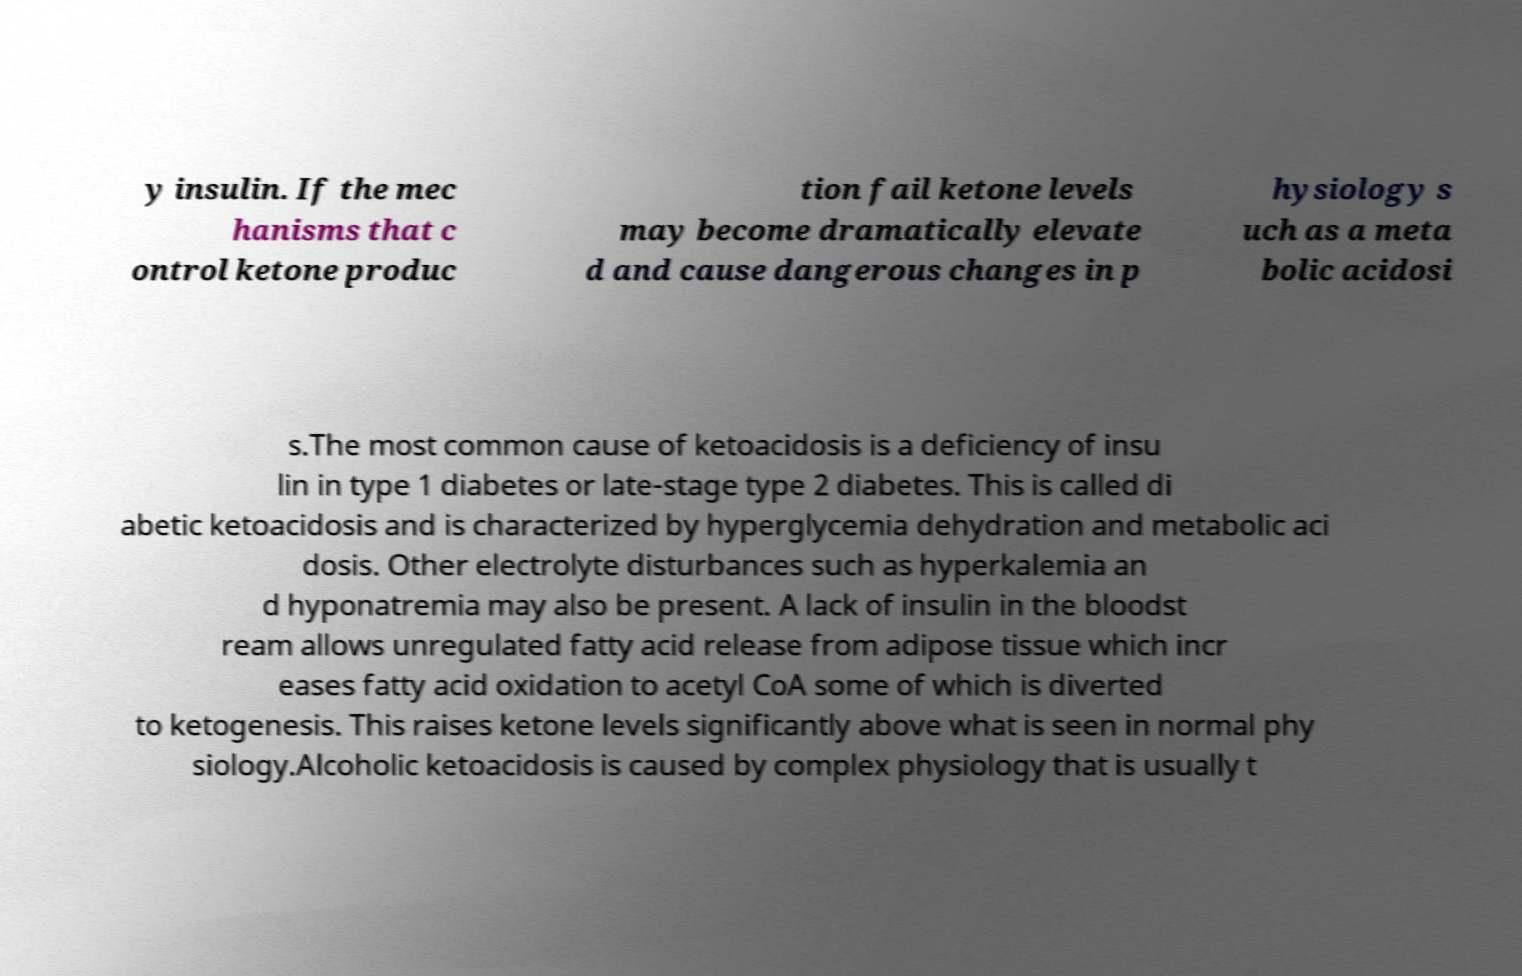Please identify and transcribe the text found in this image. y insulin. If the mec hanisms that c ontrol ketone produc tion fail ketone levels may become dramatically elevate d and cause dangerous changes in p hysiology s uch as a meta bolic acidosi s.The most common cause of ketoacidosis is a deficiency of insu lin in type 1 diabetes or late-stage type 2 diabetes. This is called di abetic ketoacidosis and is characterized by hyperglycemia dehydration and metabolic aci dosis. Other electrolyte disturbances such as hyperkalemia an d hyponatremia may also be present. A lack of insulin in the bloodst ream allows unregulated fatty acid release from adipose tissue which incr eases fatty acid oxidation to acetyl CoA some of which is diverted to ketogenesis. This raises ketone levels significantly above what is seen in normal phy siology.Alcoholic ketoacidosis is caused by complex physiology that is usually t 